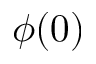Convert formula to latex. <formula><loc_0><loc_0><loc_500><loc_500>\phi ( 0 )</formula> 